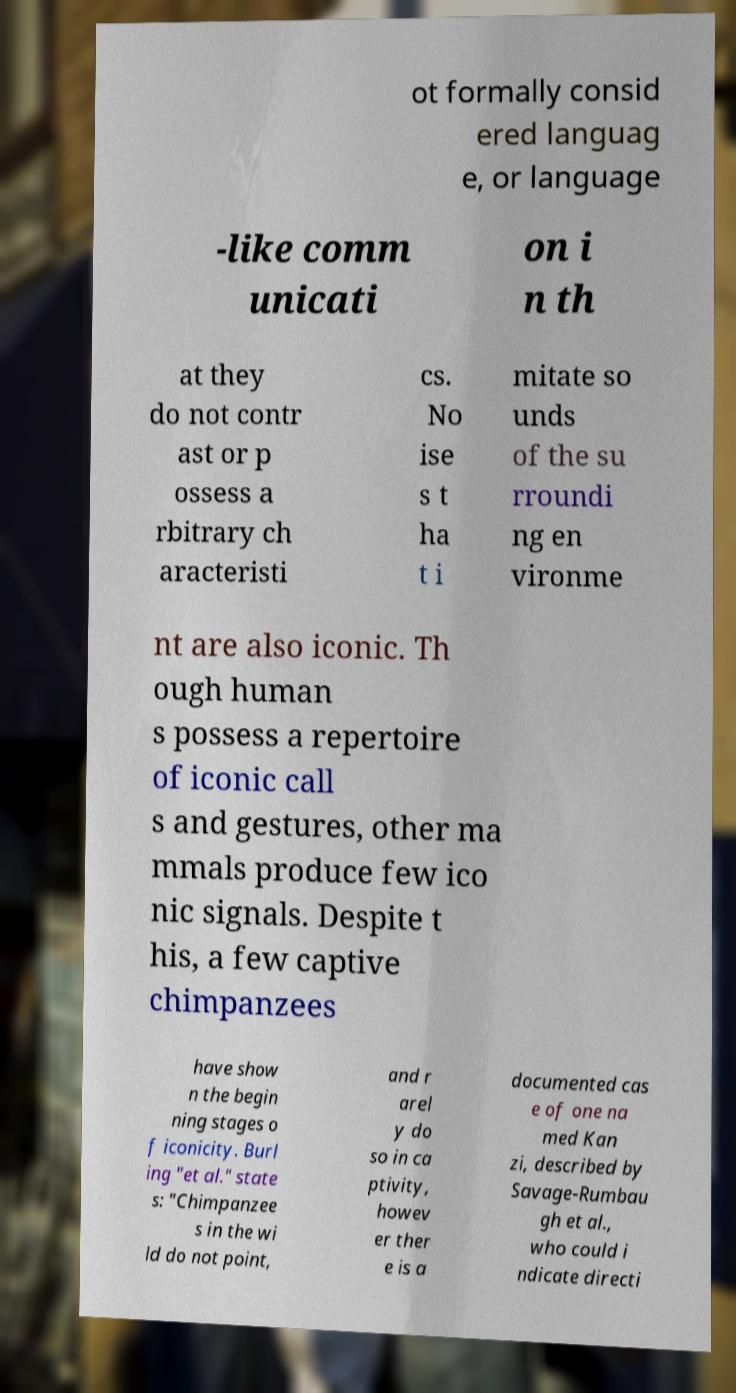Please identify and transcribe the text found in this image. ot formally consid ered languag e, or language -like comm unicati on i n th at they do not contr ast or p ossess a rbitrary ch aracteristi cs. No ise s t ha t i mitate so unds of the su rroundi ng en vironme nt are also iconic. Th ough human s possess a repertoire of iconic call s and gestures, other ma mmals produce few ico nic signals. Despite t his, a few captive chimpanzees have show n the begin ning stages o f iconicity. Burl ing "et al." state s: "Chimpanzee s in the wi ld do not point, and r arel y do so in ca ptivity, howev er ther e is a documented cas e of one na med Kan zi, described by Savage-Rumbau gh et al., who could i ndicate directi 